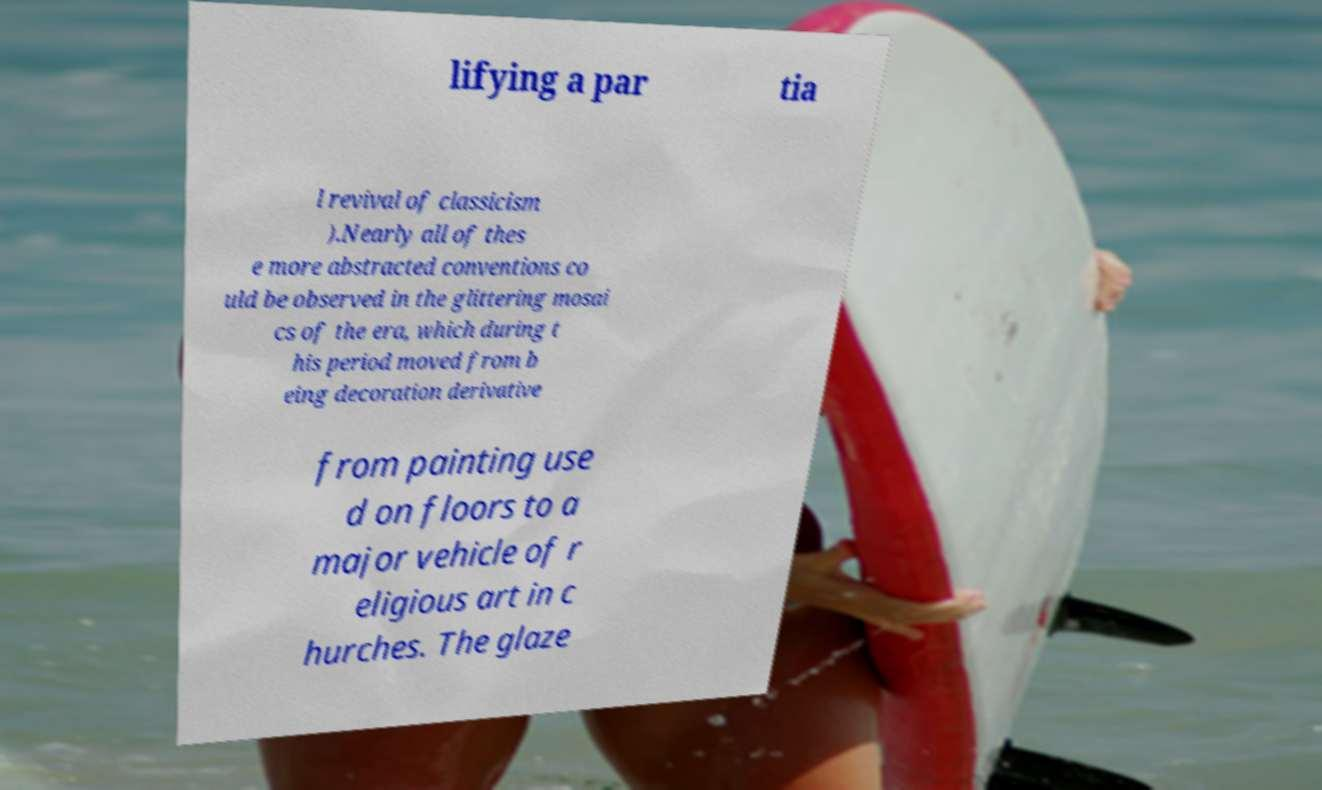There's text embedded in this image that I need extracted. Can you transcribe it verbatim? lifying a par tia l revival of classicism ).Nearly all of thes e more abstracted conventions co uld be observed in the glittering mosai cs of the era, which during t his period moved from b eing decoration derivative from painting use d on floors to a major vehicle of r eligious art in c hurches. The glaze 